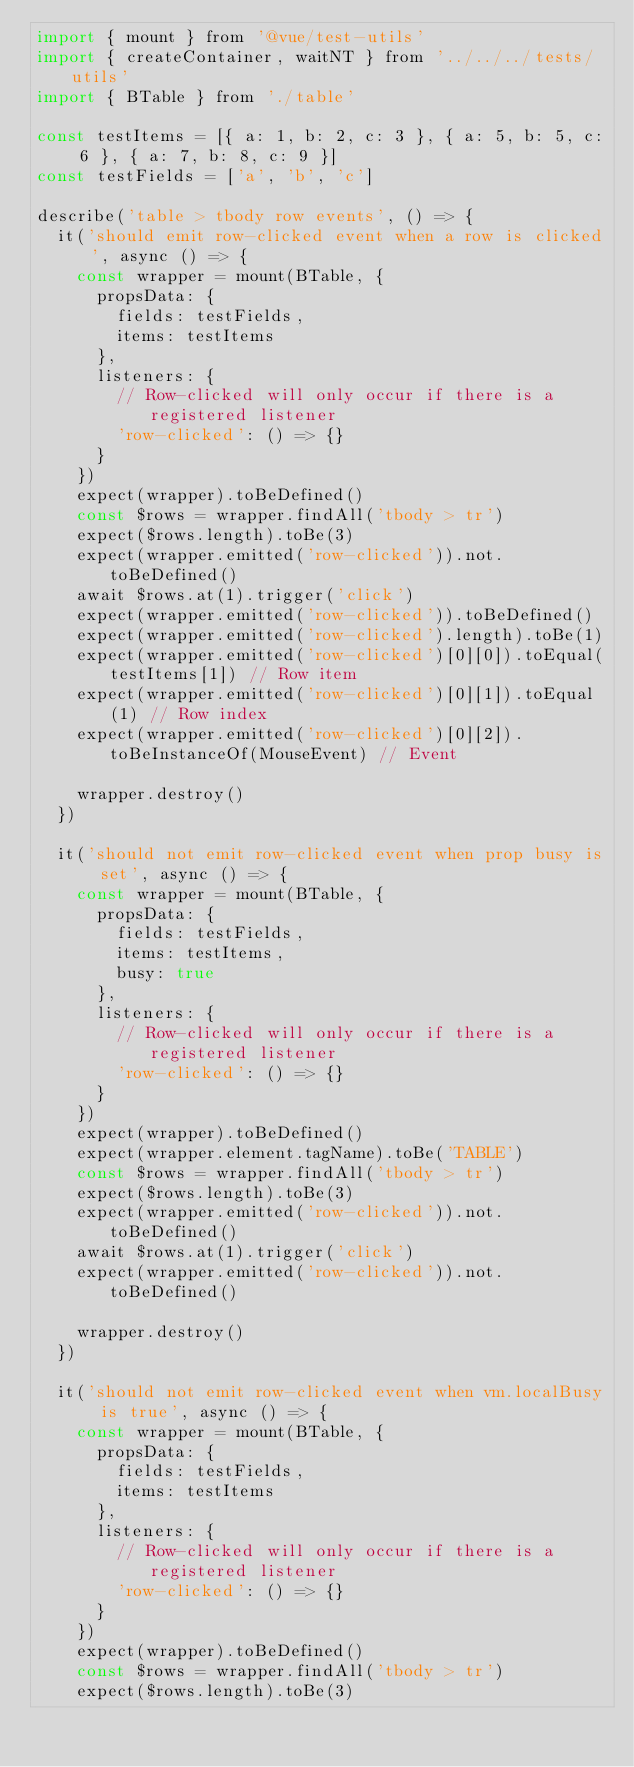Convert code to text. <code><loc_0><loc_0><loc_500><loc_500><_JavaScript_>import { mount } from '@vue/test-utils'
import { createContainer, waitNT } from '../../../tests/utils'
import { BTable } from './table'

const testItems = [{ a: 1, b: 2, c: 3 }, { a: 5, b: 5, c: 6 }, { a: 7, b: 8, c: 9 }]
const testFields = ['a', 'b', 'c']

describe('table > tbody row events', () => {
  it('should emit row-clicked event when a row is clicked', async () => {
    const wrapper = mount(BTable, {
      propsData: {
        fields: testFields,
        items: testItems
      },
      listeners: {
        // Row-clicked will only occur if there is a registered listener
        'row-clicked': () => {}
      }
    })
    expect(wrapper).toBeDefined()
    const $rows = wrapper.findAll('tbody > tr')
    expect($rows.length).toBe(3)
    expect(wrapper.emitted('row-clicked')).not.toBeDefined()
    await $rows.at(1).trigger('click')
    expect(wrapper.emitted('row-clicked')).toBeDefined()
    expect(wrapper.emitted('row-clicked').length).toBe(1)
    expect(wrapper.emitted('row-clicked')[0][0]).toEqual(testItems[1]) // Row item
    expect(wrapper.emitted('row-clicked')[0][1]).toEqual(1) // Row index
    expect(wrapper.emitted('row-clicked')[0][2]).toBeInstanceOf(MouseEvent) // Event

    wrapper.destroy()
  })

  it('should not emit row-clicked event when prop busy is set', async () => {
    const wrapper = mount(BTable, {
      propsData: {
        fields: testFields,
        items: testItems,
        busy: true
      },
      listeners: {
        // Row-clicked will only occur if there is a registered listener
        'row-clicked': () => {}
      }
    })
    expect(wrapper).toBeDefined()
    expect(wrapper.element.tagName).toBe('TABLE')
    const $rows = wrapper.findAll('tbody > tr')
    expect($rows.length).toBe(3)
    expect(wrapper.emitted('row-clicked')).not.toBeDefined()
    await $rows.at(1).trigger('click')
    expect(wrapper.emitted('row-clicked')).not.toBeDefined()

    wrapper.destroy()
  })

  it('should not emit row-clicked event when vm.localBusy is true', async () => {
    const wrapper = mount(BTable, {
      propsData: {
        fields: testFields,
        items: testItems
      },
      listeners: {
        // Row-clicked will only occur if there is a registered listener
        'row-clicked': () => {}
      }
    })
    expect(wrapper).toBeDefined()
    const $rows = wrapper.findAll('tbody > tr')
    expect($rows.length).toBe(3)</code> 